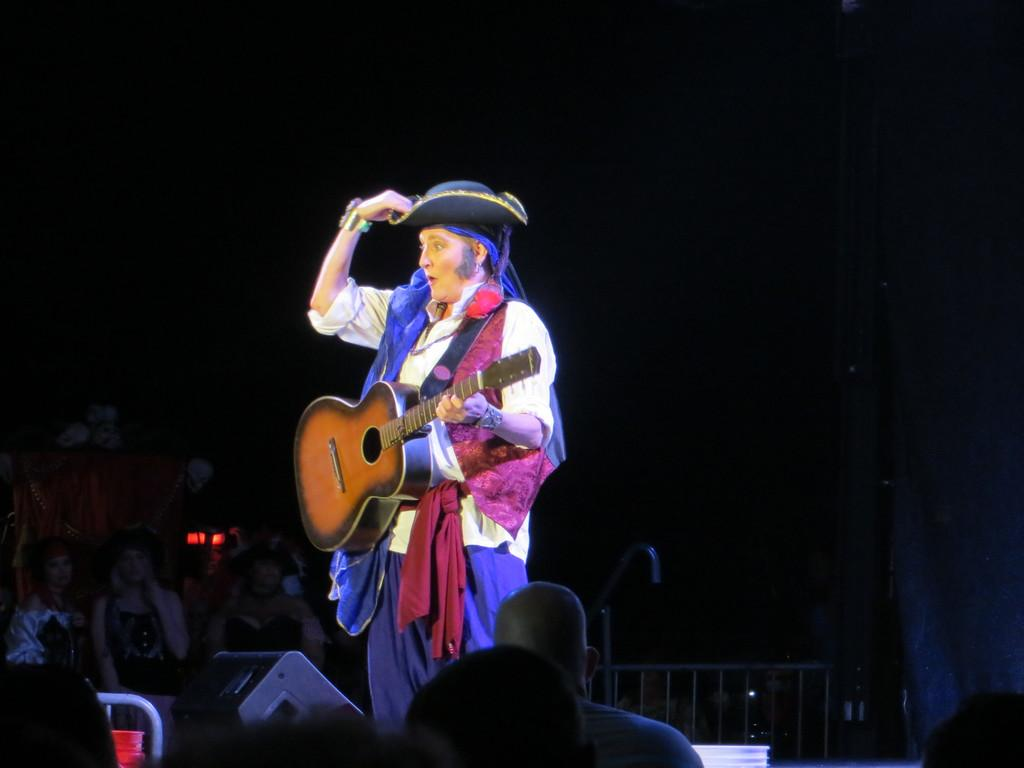What is the person in the image doing? The person is performing. What instrument is the person holding? The person is holding a guitar. What type of headwear is the person wearing? The person is wearing a hat. How many people are present in the image? There are people present in the image. What type of skin condition can be seen on the person's face in the image? There is no mention of a skin condition in the image, and the person's face is not described in the provided facts. 